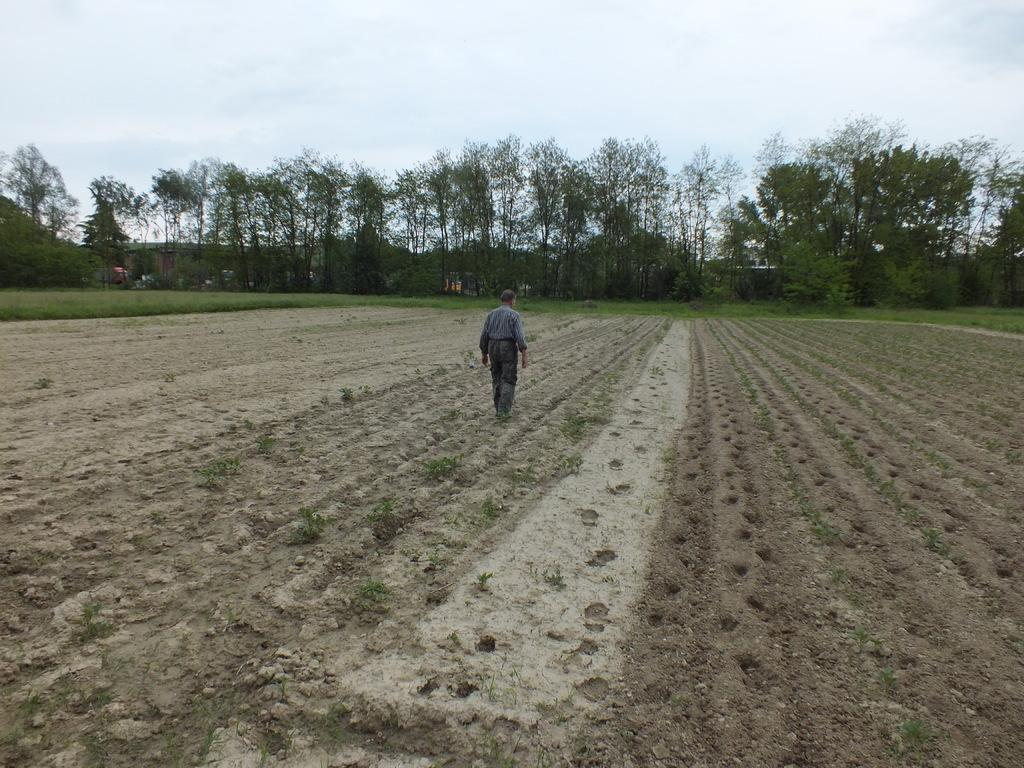What is the person in the image doing? The person is walking in the image. On what surface is the person walking? The person is walking on the ground. What type of vegetation can be seen in the image? There is green grass visible in the image. What can be seen in the background of the image? There are trees and the sky visible in the background of the image. What color is the ink on the root of the tree in the image? There is no ink or root present in the image; it features a person walking on green grass with trees and the sky visible in the background. 